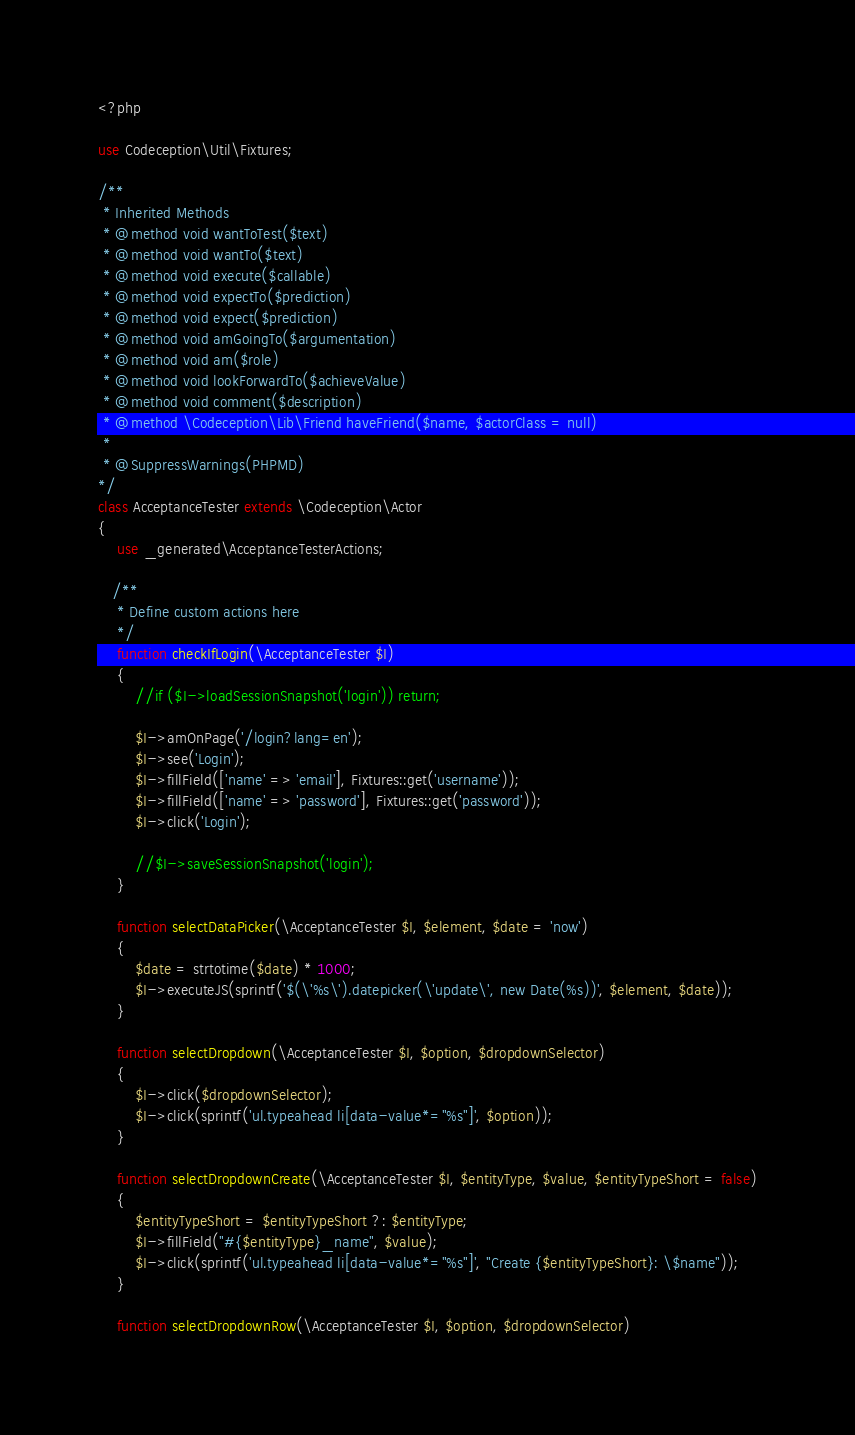Convert code to text. <code><loc_0><loc_0><loc_500><loc_500><_PHP_><?php

use Codeception\Util\Fixtures;

/**
 * Inherited Methods
 * @method void wantToTest($text)
 * @method void wantTo($text)
 * @method void execute($callable)
 * @method void expectTo($prediction)
 * @method void expect($prediction)
 * @method void amGoingTo($argumentation)
 * @method void am($role)
 * @method void lookForwardTo($achieveValue)
 * @method void comment($description)
 * @method \Codeception\Lib\Friend haveFriend($name, $actorClass = null)
 *
 * @SuppressWarnings(PHPMD)
*/
class AcceptanceTester extends \Codeception\Actor
{
    use _generated\AcceptanceTesterActions;

   /**
    * Define custom actions here
    */
    function checkIfLogin(\AcceptanceTester $I)
    {
        //if ($I->loadSessionSnapshot('login')) return;

        $I->amOnPage('/login?lang=en');
        $I->see('Login');
        $I->fillField(['name' => 'email'], Fixtures::get('username'));
        $I->fillField(['name' => 'password'], Fixtures::get('password'));
        $I->click('Login');

        //$I->saveSessionSnapshot('login');
    }

    function selectDataPicker(\AcceptanceTester $I, $element, $date = 'now')
    {
        $date = strtotime($date) * 1000;
        $I->executeJS(sprintf('$(\'%s\').datepicker(\'update\', new Date(%s))', $element, $date));
    }

    function selectDropdown(\AcceptanceTester $I, $option, $dropdownSelector)
    {
        $I->click($dropdownSelector);
        $I->click(sprintf('ul.typeahead li[data-value*="%s"]', $option));
    }

    function selectDropdownCreate(\AcceptanceTester $I, $entityType, $value, $entityTypeShort = false)
    {
        $entityTypeShort = $entityTypeShort ?: $entityType;
        $I->fillField("#{$entityType}_name", $value);
        $I->click(sprintf('ul.typeahead li[data-value*="%s"]', "Create {$entityTypeShort}: \$name"));
    }

    function selectDropdownRow(\AcceptanceTester $I, $option, $dropdownSelector)</code> 